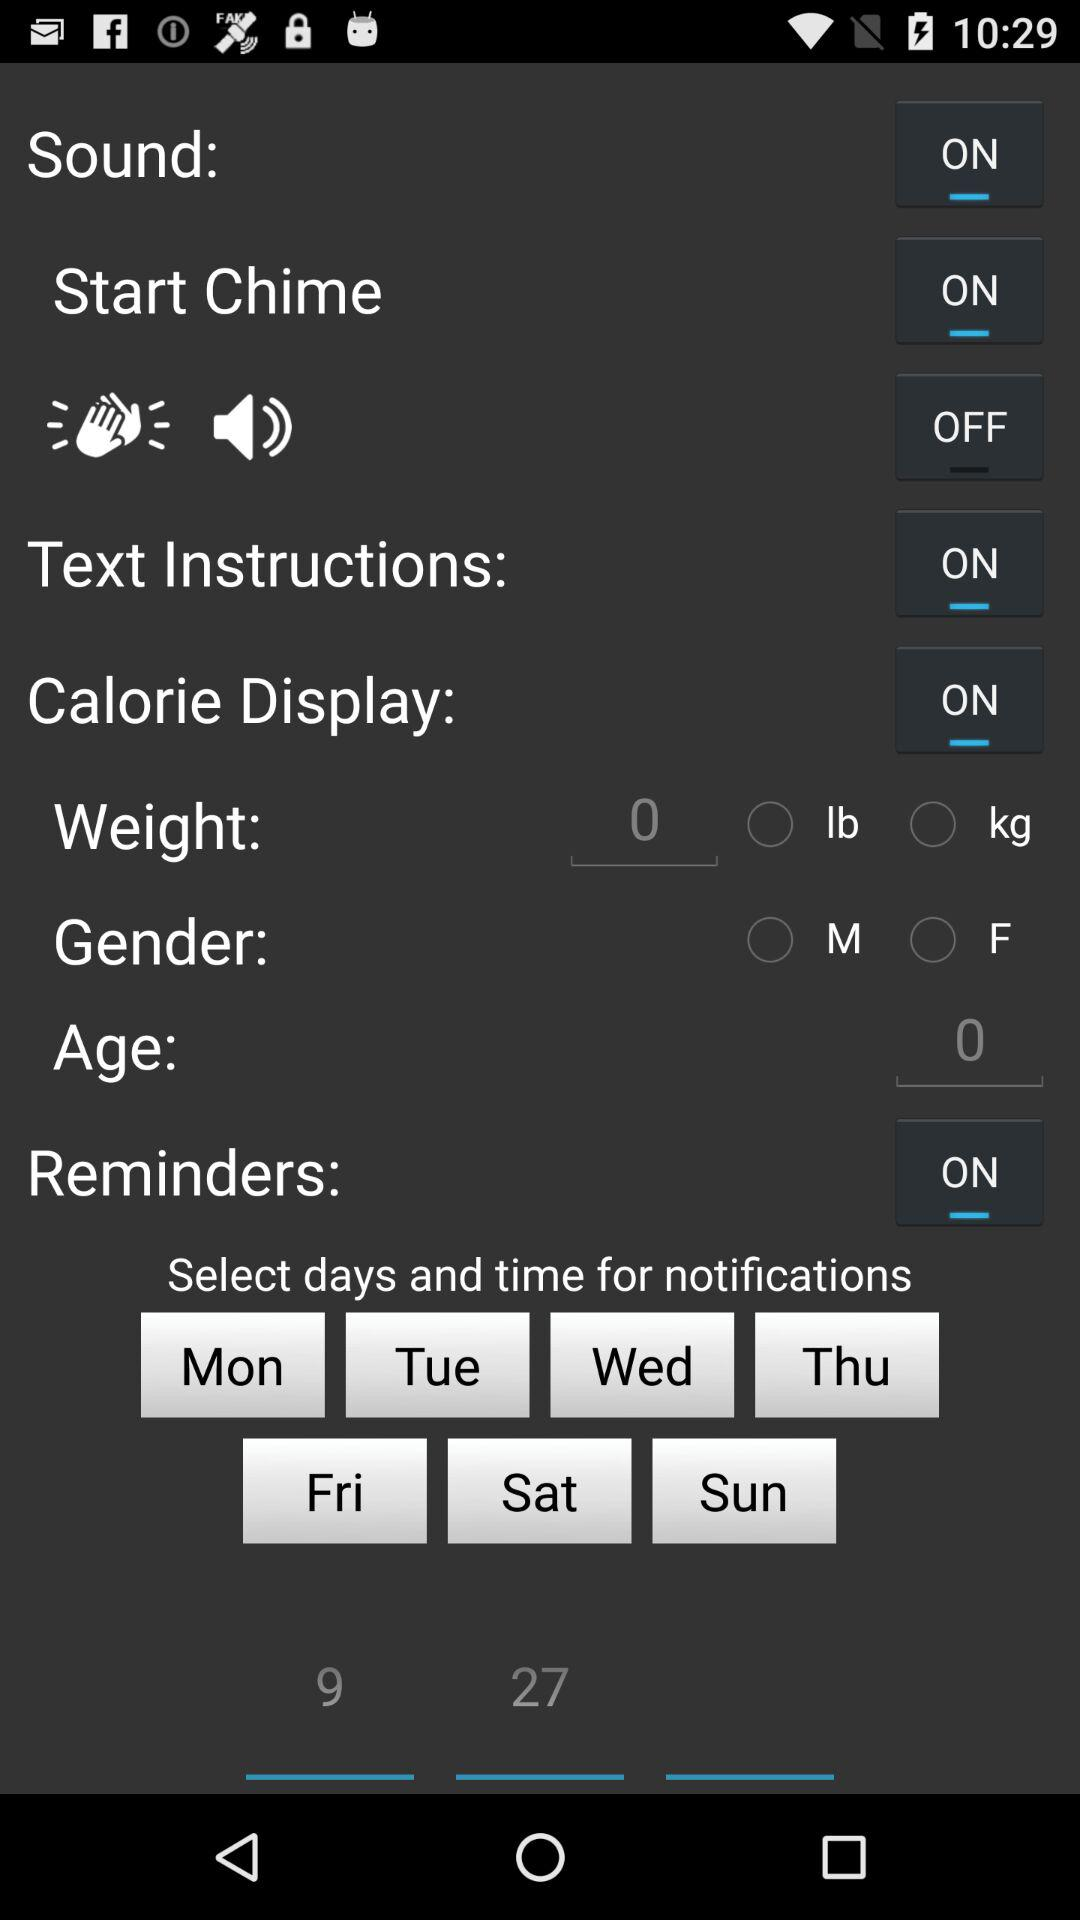What are the units of weight? The units are lb and kg. 